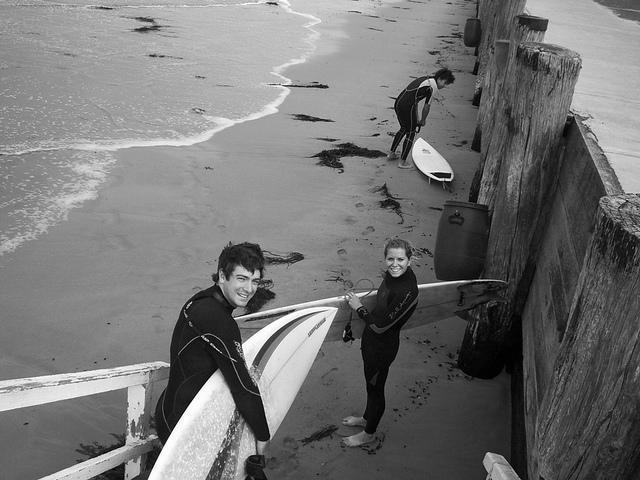How many surfboards are there?
Give a very brief answer. 2. How many people are there?
Give a very brief answer. 3. How many people on this boat are visible?
Give a very brief answer. 0. 